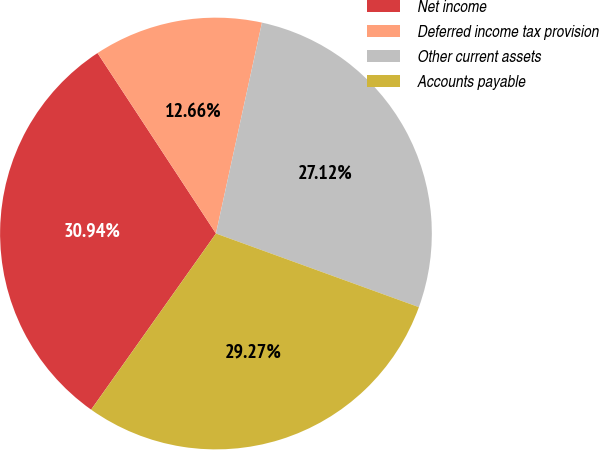<chart> <loc_0><loc_0><loc_500><loc_500><pie_chart><fcel>Net income<fcel>Deferred income tax provision<fcel>Other current assets<fcel>Accounts payable<nl><fcel>30.94%<fcel>12.66%<fcel>27.12%<fcel>29.27%<nl></chart> 